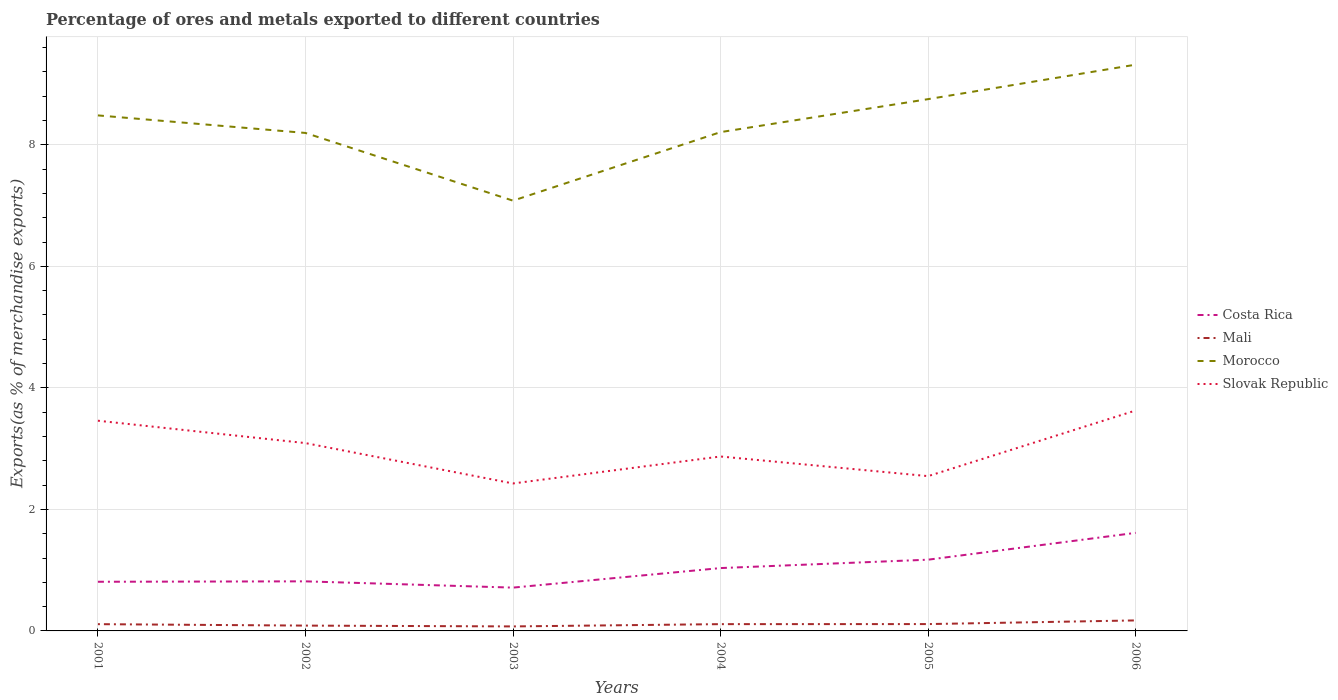Does the line corresponding to Mali intersect with the line corresponding to Slovak Republic?
Keep it short and to the point. No. Across all years, what is the maximum percentage of exports to different countries in Morocco?
Make the answer very short. 7.08. In which year was the percentage of exports to different countries in Costa Rica maximum?
Offer a terse response. 2003. What is the total percentage of exports to different countries in Costa Rica in the graph?
Ensure brevity in your answer.  0.1. What is the difference between the highest and the second highest percentage of exports to different countries in Morocco?
Give a very brief answer. 2.24. Is the percentage of exports to different countries in Morocco strictly greater than the percentage of exports to different countries in Mali over the years?
Offer a terse response. No. How many lines are there?
Provide a short and direct response. 4. How many years are there in the graph?
Your answer should be compact. 6. Are the values on the major ticks of Y-axis written in scientific E-notation?
Your answer should be compact. No. How are the legend labels stacked?
Make the answer very short. Vertical. What is the title of the graph?
Provide a succinct answer. Percentage of ores and metals exported to different countries. Does "Marshall Islands" appear as one of the legend labels in the graph?
Offer a terse response. No. What is the label or title of the X-axis?
Offer a terse response. Years. What is the label or title of the Y-axis?
Provide a succinct answer. Exports(as % of merchandise exports). What is the Exports(as % of merchandise exports) of Costa Rica in 2001?
Provide a short and direct response. 0.81. What is the Exports(as % of merchandise exports) of Mali in 2001?
Ensure brevity in your answer.  0.11. What is the Exports(as % of merchandise exports) in Morocco in 2001?
Offer a very short reply. 8.49. What is the Exports(as % of merchandise exports) of Slovak Republic in 2001?
Provide a succinct answer. 3.46. What is the Exports(as % of merchandise exports) of Costa Rica in 2002?
Your answer should be compact. 0.82. What is the Exports(as % of merchandise exports) in Mali in 2002?
Offer a very short reply. 0.09. What is the Exports(as % of merchandise exports) in Morocco in 2002?
Keep it short and to the point. 8.2. What is the Exports(as % of merchandise exports) in Slovak Republic in 2002?
Your response must be concise. 3.09. What is the Exports(as % of merchandise exports) of Costa Rica in 2003?
Ensure brevity in your answer.  0.71. What is the Exports(as % of merchandise exports) of Mali in 2003?
Ensure brevity in your answer.  0.07. What is the Exports(as % of merchandise exports) in Morocco in 2003?
Provide a short and direct response. 7.08. What is the Exports(as % of merchandise exports) of Slovak Republic in 2003?
Give a very brief answer. 2.43. What is the Exports(as % of merchandise exports) of Costa Rica in 2004?
Keep it short and to the point. 1.03. What is the Exports(as % of merchandise exports) of Mali in 2004?
Offer a very short reply. 0.11. What is the Exports(as % of merchandise exports) of Morocco in 2004?
Make the answer very short. 8.21. What is the Exports(as % of merchandise exports) of Slovak Republic in 2004?
Keep it short and to the point. 2.87. What is the Exports(as % of merchandise exports) in Costa Rica in 2005?
Ensure brevity in your answer.  1.17. What is the Exports(as % of merchandise exports) in Mali in 2005?
Your response must be concise. 0.11. What is the Exports(as % of merchandise exports) of Morocco in 2005?
Your response must be concise. 8.75. What is the Exports(as % of merchandise exports) in Slovak Republic in 2005?
Provide a short and direct response. 2.55. What is the Exports(as % of merchandise exports) in Costa Rica in 2006?
Your answer should be very brief. 1.61. What is the Exports(as % of merchandise exports) in Mali in 2006?
Provide a short and direct response. 0.17. What is the Exports(as % of merchandise exports) in Morocco in 2006?
Give a very brief answer. 9.32. What is the Exports(as % of merchandise exports) in Slovak Republic in 2006?
Offer a terse response. 3.63. Across all years, what is the maximum Exports(as % of merchandise exports) in Costa Rica?
Offer a very short reply. 1.61. Across all years, what is the maximum Exports(as % of merchandise exports) of Mali?
Your answer should be very brief. 0.17. Across all years, what is the maximum Exports(as % of merchandise exports) of Morocco?
Your answer should be very brief. 9.32. Across all years, what is the maximum Exports(as % of merchandise exports) in Slovak Republic?
Keep it short and to the point. 3.63. Across all years, what is the minimum Exports(as % of merchandise exports) of Costa Rica?
Offer a very short reply. 0.71. Across all years, what is the minimum Exports(as % of merchandise exports) of Mali?
Give a very brief answer. 0.07. Across all years, what is the minimum Exports(as % of merchandise exports) of Morocco?
Give a very brief answer. 7.08. Across all years, what is the minimum Exports(as % of merchandise exports) of Slovak Republic?
Offer a terse response. 2.43. What is the total Exports(as % of merchandise exports) of Costa Rica in the graph?
Offer a terse response. 6.16. What is the total Exports(as % of merchandise exports) in Mali in the graph?
Provide a succinct answer. 0.67. What is the total Exports(as % of merchandise exports) of Morocco in the graph?
Your answer should be very brief. 50.05. What is the total Exports(as % of merchandise exports) in Slovak Republic in the graph?
Make the answer very short. 18.03. What is the difference between the Exports(as % of merchandise exports) of Costa Rica in 2001 and that in 2002?
Make the answer very short. -0.01. What is the difference between the Exports(as % of merchandise exports) in Mali in 2001 and that in 2002?
Your answer should be very brief. 0.02. What is the difference between the Exports(as % of merchandise exports) in Morocco in 2001 and that in 2002?
Ensure brevity in your answer.  0.29. What is the difference between the Exports(as % of merchandise exports) in Slovak Republic in 2001 and that in 2002?
Provide a short and direct response. 0.37. What is the difference between the Exports(as % of merchandise exports) in Costa Rica in 2001 and that in 2003?
Provide a succinct answer. 0.1. What is the difference between the Exports(as % of merchandise exports) of Mali in 2001 and that in 2003?
Give a very brief answer. 0.04. What is the difference between the Exports(as % of merchandise exports) of Morocco in 2001 and that in 2003?
Offer a very short reply. 1.4. What is the difference between the Exports(as % of merchandise exports) in Slovak Republic in 2001 and that in 2003?
Offer a very short reply. 1.03. What is the difference between the Exports(as % of merchandise exports) in Costa Rica in 2001 and that in 2004?
Make the answer very short. -0.23. What is the difference between the Exports(as % of merchandise exports) of Mali in 2001 and that in 2004?
Keep it short and to the point. -0. What is the difference between the Exports(as % of merchandise exports) of Morocco in 2001 and that in 2004?
Your answer should be compact. 0.28. What is the difference between the Exports(as % of merchandise exports) in Slovak Republic in 2001 and that in 2004?
Offer a terse response. 0.59. What is the difference between the Exports(as % of merchandise exports) of Costa Rica in 2001 and that in 2005?
Offer a very short reply. -0.36. What is the difference between the Exports(as % of merchandise exports) in Mali in 2001 and that in 2005?
Offer a terse response. -0. What is the difference between the Exports(as % of merchandise exports) of Morocco in 2001 and that in 2005?
Provide a succinct answer. -0.27. What is the difference between the Exports(as % of merchandise exports) of Slovak Republic in 2001 and that in 2005?
Give a very brief answer. 0.91. What is the difference between the Exports(as % of merchandise exports) in Costa Rica in 2001 and that in 2006?
Ensure brevity in your answer.  -0.8. What is the difference between the Exports(as % of merchandise exports) in Mali in 2001 and that in 2006?
Keep it short and to the point. -0.06. What is the difference between the Exports(as % of merchandise exports) in Morocco in 2001 and that in 2006?
Offer a terse response. -0.84. What is the difference between the Exports(as % of merchandise exports) of Slovak Republic in 2001 and that in 2006?
Give a very brief answer. -0.17. What is the difference between the Exports(as % of merchandise exports) of Costa Rica in 2002 and that in 2003?
Make the answer very short. 0.1. What is the difference between the Exports(as % of merchandise exports) in Mali in 2002 and that in 2003?
Your answer should be compact. 0.01. What is the difference between the Exports(as % of merchandise exports) of Morocco in 2002 and that in 2003?
Give a very brief answer. 1.11. What is the difference between the Exports(as % of merchandise exports) in Slovak Republic in 2002 and that in 2003?
Offer a terse response. 0.66. What is the difference between the Exports(as % of merchandise exports) in Costa Rica in 2002 and that in 2004?
Your response must be concise. -0.22. What is the difference between the Exports(as % of merchandise exports) in Mali in 2002 and that in 2004?
Give a very brief answer. -0.02. What is the difference between the Exports(as % of merchandise exports) in Morocco in 2002 and that in 2004?
Keep it short and to the point. -0.01. What is the difference between the Exports(as % of merchandise exports) in Slovak Republic in 2002 and that in 2004?
Provide a short and direct response. 0.22. What is the difference between the Exports(as % of merchandise exports) in Costa Rica in 2002 and that in 2005?
Offer a terse response. -0.36. What is the difference between the Exports(as % of merchandise exports) of Mali in 2002 and that in 2005?
Make the answer very short. -0.03. What is the difference between the Exports(as % of merchandise exports) in Morocco in 2002 and that in 2005?
Offer a terse response. -0.56. What is the difference between the Exports(as % of merchandise exports) in Slovak Republic in 2002 and that in 2005?
Provide a short and direct response. 0.54. What is the difference between the Exports(as % of merchandise exports) in Costa Rica in 2002 and that in 2006?
Offer a very short reply. -0.8. What is the difference between the Exports(as % of merchandise exports) in Mali in 2002 and that in 2006?
Offer a very short reply. -0.09. What is the difference between the Exports(as % of merchandise exports) of Morocco in 2002 and that in 2006?
Give a very brief answer. -1.12. What is the difference between the Exports(as % of merchandise exports) of Slovak Republic in 2002 and that in 2006?
Ensure brevity in your answer.  -0.54. What is the difference between the Exports(as % of merchandise exports) of Costa Rica in 2003 and that in 2004?
Offer a terse response. -0.32. What is the difference between the Exports(as % of merchandise exports) of Mali in 2003 and that in 2004?
Ensure brevity in your answer.  -0.04. What is the difference between the Exports(as % of merchandise exports) in Morocco in 2003 and that in 2004?
Give a very brief answer. -1.13. What is the difference between the Exports(as % of merchandise exports) of Slovak Republic in 2003 and that in 2004?
Your answer should be compact. -0.44. What is the difference between the Exports(as % of merchandise exports) of Costa Rica in 2003 and that in 2005?
Offer a very short reply. -0.46. What is the difference between the Exports(as % of merchandise exports) of Mali in 2003 and that in 2005?
Provide a succinct answer. -0.04. What is the difference between the Exports(as % of merchandise exports) in Morocco in 2003 and that in 2005?
Offer a terse response. -1.67. What is the difference between the Exports(as % of merchandise exports) of Slovak Republic in 2003 and that in 2005?
Offer a very short reply. -0.12. What is the difference between the Exports(as % of merchandise exports) of Costa Rica in 2003 and that in 2006?
Keep it short and to the point. -0.9. What is the difference between the Exports(as % of merchandise exports) in Mali in 2003 and that in 2006?
Make the answer very short. -0.1. What is the difference between the Exports(as % of merchandise exports) in Morocco in 2003 and that in 2006?
Your answer should be compact. -2.24. What is the difference between the Exports(as % of merchandise exports) of Slovak Republic in 2003 and that in 2006?
Your response must be concise. -1.2. What is the difference between the Exports(as % of merchandise exports) of Costa Rica in 2004 and that in 2005?
Provide a short and direct response. -0.14. What is the difference between the Exports(as % of merchandise exports) of Mali in 2004 and that in 2005?
Offer a very short reply. -0. What is the difference between the Exports(as % of merchandise exports) of Morocco in 2004 and that in 2005?
Give a very brief answer. -0.54. What is the difference between the Exports(as % of merchandise exports) of Slovak Republic in 2004 and that in 2005?
Offer a very short reply. 0.32. What is the difference between the Exports(as % of merchandise exports) of Costa Rica in 2004 and that in 2006?
Keep it short and to the point. -0.58. What is the difference between the Exports(as % of merchandise exports) in Mali in 2004 and that in 2006?
Offer a terse response. -0.06. What is the difference between the Exports(as % of merchandise exports) in Morocco in 2004 and that in 2006?
Provide a short and direct response. -1.11. What is the difference between the Exports(as % of merchandise exports) in Slovak Republic in 2004 and that in 2006?
Offer a terse response. -0.76. What is the difference between the Exports(as % of merchandise exports) of Costa Rica in 2005 and that in 2006?
Offer a very short reply. -0.44. What is the difference between the Exports(as % of merchandise exports) of Mali in 2005 and that in 2006?
Your answer should be very brief. -0.06. What is the difference between the Exports(as % of merchandise exports) of Morocco in 2005 and that in 2006?
Make the answer very short. -0.57. What is the difference between the Exports(as % of merchandise exports) of Slovak Republic in 2005 and that in 2006?
Make the answer very short. -1.08. What is the difference between the Exports(as % of merchandise exports) of Costa Rica in 2001 and the Exports(as % of merchandise exports) of Mali in 2002?
Give a very brief answer. 0.72. What is the difference between the Exports(as % of merchandise exports) in Costa Rica in 2001 and the Exports(as % of merchandise exports) in Morocco in 2002?
Ensure brevity in your answer.  -7.39. What is the difference between the Exports(as % of merchandise exports) in Costa Rica in 2001 and the Exports(as % of merchandise exports) in Slovak Republic in 2002?
Your response must be concise. -2.28. What is the difference between the Exports(as % of merchandise exports) in Mali in 2001 and the Exports(as % of merchandise exports) in Morocco in 2002?
Ensure brevity in your answer.  -8.09. What is the difference between the Exports(as % of merchandise exports) of Mali in 2001 and the Exports(as % of merchandise exports) of Slovak Republic in 2002?
Make the answer very short. -2.98. What is the difference between the Exports(as % of merchandise exports) of Morocco in 2001 and the Exports(as % of merchandise exports) of Slovak Republic in 2002?
Offer a very short reply. 5.39. What is the difference between the Exports(as % of merchandise exports) of Costa Rica in 2001 and the Exports(as % of merchandise exports) of Mali in 2003?
Provide a succinct answer. 0.74. What is the difference between the Exports(as % of merchandise exports) of Costa Rica in 2001 and the Exports(as % of merchandise exports) of Morocco in 2003?
Keep it short and to the point. -6.27. What is the difference between the Exports(as % of merchandise exports) in Costa Rica in 2001 and the Exports(as % of merchandise exports) in Slovak Republic in 2003?
Provide a succinct answer. -1.62. What is the difference between the Exports(as % of merchandise exports) of Mali in 2001 and the Exports(as % of merchandise exports) of Morocco in 2003?
Your answer should be compact. -6.97. What is the difference between the Exports(as % of merchandise exports) in Mali in 2001 and the Exports(as % of merchandise exports) in Slovak Republic in 2003?
Offer a terse response. -2.32. What is the difference between the Exports(as % of merchandise exports) of Morocco in 2001 and the Exports(as % of merchandise exports) of Slovak Republic in 2003?
Your answer should be very brief. 6.06. What is the difference between the Exports(as % of merchandise exports) in Costa Rica in 2001 and the Exports(as % of merchandise exports) in Mali in 2004?
Ensure brevity in your answer.  0.7. What is the difference between the Exports(as % of merchandise exports) in Costa Rica in 2001 and the Exports(as % of merchandise exports) in Morocco in 2004?
Give a very brief answer. -7.4. What is the difference between the Exports(as % of merchandise exports) of Costa Rica in 2001 and the Exports(as % of merchandise exports) of Slovak Republic in 2004?
Ensure brevity in your answer.  -2.06. What is the difference between the Exports(as % of merchandise exports) in Mali in 2001 and the Exports(as % of merchandise exports) in Morocco in 2004?
Your answer should be compact. -8.1. What is the difference between the Exports(as % of merchandise exports) in Mali in 2001 and the Exports(as % of merchandise exports) in Slovak Republic in 2004?
Keep it short and to the point. -2.76. What is the difference between the Exports(as % of merchandise exports) of Morocco in 2001 and the Exports(as % of merchandise exports) of Slovak Republic in 2004?
Your answer should be compact. 5.61. What is the difference between the Exports(as % of merchandise exports) of Costa Rica in 2001 and the Exports(as % of merchandise exports) of Mali in 2005?
Provide a short and direct response. 0.7. What is the difference between the Exports(as % of merchandise exports) in Costa Rica in 2001 and the Exports(as % of merchandise exports) in Morocco in 2005?
Provide a succinct answer. -7.94. What is the difference between the Exports(as % of merchandise exports) in Costa Rica in 2001 and the Exports(as % of merchandise exports) in Slovak Republic in 2005?
Ensure brevity in your answer.  -1.74. What is the difference between the Exports(as % of merchandise exports) of Mali in 2001 and the Exports(as % of merchandise exports) of Morocco in 2005?
Provide a short and direct response. -8.64. What is the difference between the Exports(as % of merchandise exports) of Mali in 2001 and the Exports(as % of merchandise exports) of Slovak Republic in 2005?
Provide a short and direct response. -2.44. What is the difference between the Exports(as % of merchandise exports) in Morocco in 2001 and the Exports(as % of merchandise exports) in Slovak Republic in 2005?
Make the answer very short. 5.94. What is the difference between the Exports(as % of merchandise exports) in Costa Rica in 2001 and the Exports(as % of merchandise exports) in Mali in 2006?
Your answer should be compact. 0.64. What is the difference between the Exports(as % of merchandise exports) in Costa Rica in 2001 and the Exports(as % of merchandise exports) in Morocco in 2006?
Provide a short and direct response. -8.51. What is the difference between the Exports(as % of merchandise exports) in Costa Rica in 2001 and the Exports(as % of merchandise exports) in Slovak Republic in 2006?
Your answer should be very brief. -2.82. What is the difference between the Exports(as % of merchandise exports) of Mali in 2001 and the Exports(as % of merchandise exports) of Morocco in 2006?
Provide a short and direct response. -9.21. What is the difference between the Exports(as % of merchandise exports) in Mali in 2001 and the Exports(as % of merchandise exports) in Slovak Republic in 2006?
Your answer should be compact. -3.52. What is the difference between the Exports(as % of merchandise exports) in Morocco in 2001 and the Exports(as % of merchandise exports) in Slovak Republic in 2006?
Your response must be concise. 4.86. What is the difference between the Exports(as % of merchandise exports) in Costa Rica in 2002 and the Exports(as % of merchandise exports) in Mali in 2003?
Your response must be concise. 0.74. What is the difference between the Exports(as % of merchandise exports) of Costa Rica in 2002 and the Exports(as % of merchandise exports) of Morocco in 2003?
Ensure brevity in your answer.  -6.27. What is the difference between the Exports(as % of merchandise exports) of Costa Rica in 2002 and the Exports(as % of merchandise exports) of Slovak Republic in 2003?
Offer a very short reply. -1.61. What is the difference between the Exports(as % of merchandise exports) of Mali in 2002 and the Exports(as % of merchandise exports) of Morocco in 2003?
Ensure brevity in your answer.  -6.99. What is the difference between the Exports(as % of merchandise exports) of Mali in 2002 and the Exports(as % of merchandise exports) of Slovak Republic in 2003?
Provide a short and direct response. -2.34. What is the difference between the Exports(as % of merchandise exports) of Morocco in 2002 and the Exports(as % of merchandise exports) of Slovak Republic in 2003?
Give a very brief answer. 5.77. What is the difference between the Exports(as % of merchandise exports) in Costa Rica in 2002 and the Exports(as % of merchandise exports) in Mali in 2004?
Your answer should be compact. 0.7. What is the difference between the Exports(as % of merchandise exports) of Costa Rica in 2002 and the Exports(as % of merchandise exports) of Morocco in 2004?
Provide a short and direct response. -7.39. What is the difference between the Exports(as % of merchandise exports) in Costa Rica in 2002 and the Exports(as % of merchandise exports) in Slovak Republic in 2004?
Make the answer very short. -2.06. What is the difference between the Exports(as % of merchandise exports) in Mali in 2002 and the Exports(as % of merchandise exports) in Morocco in 2004?
Make the answer very short. -8.12. What is the difference between the Exports(as % of merchandise exports) in Mali in 2002 and the Exports(as % of merchandise exports) in Slovak Republic in 2004?
Make the answer very short. -2.78. What is the difference between the Exports(as % of merchandise exports) in Morocco in 2002 and the Exports(as % of merchandise exports) in Slovak Republic in 2004?
Your answer should be very brief. 5.33. What is the difference between the Exports(as % of merchandise exports) in Costa Rica in 2002 and the Exports(as % of merchandise exports) in Mali in 2005?
Keep it short and to the point. 0.7. What is the difference between the Exports(as % of merchandise exports) of Costa Rica in 2002 and the Exports(as % of merchandise exports) of Morocco in 2005?
Give a very brief answer. -7.94. What is the difference between the Exports(as % of merchandise exports) in Costa Rica in 2002 and the Exports(as % of merchandise exports) in Slovak Republic in 2005?
Provide a succinct answer. -1.73. What is the difference between the Exports(as % of merchandise exports) in Mali in 2002 and the Exports(as % of merchandise exports) in Morocco in 2005?
Provide a short and direct response. -8.67. What is the difference between the Exports(as % of merchandise exports) of Mali in 2002 and the Exports(as % of merchandise exports) of Slovak Republic in 2005?
Keep it short and to the point. -2.46. What is the difference between the Exports(as % of merchandise exports) in Morocco in 2002 and the Exports(as % of merchandise exports) in Slovak Republic in 2005?
Offer a terse response. 5.65. What is the difference between the Exports(as % of merchandise exports) of Costa Rica in 2002 and the Exports(as % of merchandise exports) of Mali in 2006?
Offer a very short reply. 0.64. What is the difference between the Exports(as % of merchandise exports) in Costa Rica in 2002 and the Exports(as % of merchandise exports) in Morocco in 2006?
Keep it short and to the point. -8.5. What is the difference between the Exports(as % of merchandise exports) of Costa Rica in 2002 and the Exports(as % of merchandise exports) of Slovak Republic in 2006?
Provide a short and direct response. -2.81. What is the difference between the Exports(as % of merchandise exports) in Mali in 2002 and the Exports(as % of merchandise exports) in Morocco in 2006?
Your response must be concise. -9.23. What is the difference between the Exports(as % of merchandise exports) of Mali in 2002 and the Exports(as % of merchandise exports) of Slovak Republic in 2006?
Give a very brief answer. -3.54. What is the difference between the Exports(as % of merchandise exports) of Morocco in 2002 and the Exports(as % of merchandise exports) of Slovak Republic in 2006?
Your answer should be compact. 4.57. What is the difference between the Exports(as % of merchandise exports) of Costa Rica in 2003 and the Exports(as % of merchandise exports) of Mali in 2004?
Give a very brief answer. 0.6. What is the difference between the Exports(as % of merchandise exports) of Costa Rica in 2003 and the Exports(as % of merchandise exports) of Morocco in 2004?
Keep it short and to the point. -7.5. What is the difference between the Exports(as % of merchandise exports) of Costa Rica in 2003 and the Exports(as % of merchandise exports) of Slovak Republic in 2004?
Provide a short and direct response. -2.16. What is the difference between the Exports(as % of merchandise exports) of Mali in 2003 and the Exports(as % of merchandise exports) of Morocco in 2004?
Provide a succinct answer. -8.14. What is the difference between the Exports(as % of merchandise exports) in Mali in 2003 and the Exports(as % of merchandise exports) in Slovak Republic in 2004?
Offer a very short reply. -2.8. What is the difference between the Exports(as % of merchandise exports) in Morocco in 2003 and the Exports(as % of merchandise exports) in Slovak Republic in 2004?
Your answer should be compact. 4.21. What is the difference between the Exports(as % of merchandise exports) of Costa Rica in 2003 and the Exports(as % of merchandise exports) of Mali in 2005?
Provide a succinct answer. 0.6. What is the difference between the Exports(as % of merchandise exports) in Costa Rica in 2003 and the Exports(as % of merchandise exports) in Morocco in 2005?
Give a very brief answer. -8.04. What is the difference between the Exports(as % of merchandise exports) in Costa Rica in 2003 and the Exports(as % of merchandise exports) in Slovak Republic in 2005?
Provide a succinct answer. -1.83. What is the difference between the Exports(as % of merchandise exports) of Mali in 2003 and the Exports(as % of merchandise exports) of Morocco in 2005?
Keep it short and to the point. -8.68. What is the difference between the Exports(as % of merchandise exports) of Mali in 2003 and the Exports(as % of merchandise exports) of Slovak Republic in 2005?
Your response must be concise. -2.47. What is the difference between the Exports(as % of merchandise exports) in Morocco in 2003 and the Exports(as % of merchandise exports) in Slovak Republic in 2005?
Your response must be concise. 4.53. What is the difference between the Exports(as % of merchandise exports) of Costa Rica in 2003 and the Exports(as % of merchandise exports) of Mali in 2006?
Your response must be concise. 0.54. What is the difference between the Exports(as % of merchandise exports) in Costa Rica in 2003 and the Exports(as % of merchandise exports) in Morocco in 2006?
Make the answer very short. -8.61. What is the difference between the Exports(as % of merchandise exports) of Costa Rica in 2003 and the Exports(as % of merchandise exports) of Slovak Republic in 2006?
Your answer should be very brief. -2.92. What is the difference between the Exports(as % of merchandise exports) in Mali in 2003 and the Exports(as % of merchandise exports) in Morocco in 2006?
Keep it short and to the point. -9.25. What is the difference between the Exports(as % of merchandise exports) in Mali in 2003 and the Exports(as % of merchandise exports) in Slovak Republic in 2006?
Offer a very short reply. -3.55. What is the difference between the Exports(as % of merchandise exports) of Morocco in 2003 and the Exports(as % of merchandise exports) of Slovak Republic in 2006?
Make the answer very short. 3.45. What is the difference between the Exports(as % of merchandise exports) of Costa Rica in 2004 and the Exports(as % of merchandise exports) of Mali in 2005?
Offer a very short reply. 0.92. What is the difference between the Exports(as % of merchandise exports) of Costa Rica in 2004 and the Exports(as % of merchandise exports) of Morocco in 2005?
Your answer should be compact. -7.72. What is the difference between the Exports(as % of merchandise exports) in Costa Rica in 2004 and the Exports(as % of merchandise exports) in Slovak Republic in 2005?
Your answer should be compact. -1.51. What is the difference between the Exports(as % of merchandise exports) in Mali in 2004 and the Exports(as % of merchandise exports) in Morocco in 2005?
Provide a succinct answer. -8.64. What is the difference between the Exports(as % of merchandise exports) of Mali in 2004 and the Exports(as % of merchandise exports) of Slovak Republic in 2005?
Offer a very short reply. -2.44. What is the difference between the Exports(as % of merchandise exports) in Morocco in 2004 and the Exports(as % of merchandise exports) in Slovak Republic in 2005?
Provide a succinct answer. 5.66. What is the difference between the Exports(as % of merchandise exports) in Costa Rica in 2004 and the Exports(as % of merchandise exports) in Mali in 2006?
Ensure brevity in your answer.  0.86. What is the difference between the Exports(as % of merchandise exports) in Costa Rica in 2004 and the Exports(as % of merchandise exports) in Morocco in 2006?
Give a very brief answer. -8.29. What is the difference between the Exports(as % of merchandise exports) of Costa Rica in 2004 and the Exports(as % of merchandise exports) of Slovak Republic in 2006?
Ensure brevity in your answer.  -2.59. What is the difference between the Exports(as % of merchandise exports) of Mali in 2004 and the Exports(as % of merchandise exports) of Morocco in 2006?
Make the answer very short. -9.21. What is the difference between the Exports(as % of merchandise exports) in Mali in 2004 and the Exports(as % of merchandise exports) in Slovak Republic in 2006?
Your answer should be compact. -3.52. What is the difference between the Exports(as % of merchandise exports) of Morocco in 2004 and the Exports(as % of merchandise exports) of Slovak Republic in 2006?
Keep it short and to the point. 4.58. What is the difference between the Exports(as % of merchandise exports) of Costa Rica in 2005 and the Exports(as % of merchandise exports) of Mali in 2006?
Make the answer very short. 1. What is the difference between the Exports(as % of merchandise exports) in Costa Rica in 2005 and the Exports(as % of merchandise exports) in Morocco in 2006?
Keep it short and to the point. -8.15. What is the difference between the Exports(as % of merchandise exports) in Costa Rica in 2005 and the Exports(as % of merchandise exports) in Slovak Republic in 2006?
Your response must be concise. -2.46. What is the difference between the Exports(as % of merchandise exports) of Mali in 2005 and the Exports(as % of merchandise exports) of Morocco in 2006?
Your answer should be compact. -9.21. What is the difference between the Exports(as % of merchandise exports) of Mali in 2005 and the Exports(as % of merchandise exports) of Slovak Republic in 2006?
Provide a short and direct response. -3.52. What is the difference between the Exports(as % of merchandise exports) of Morocco in 2005 and the Exports(as % of merchandise exports) of Slovak Republic in 2006?
Offer a terse response. 5.12. What is the average Exports(as % of merchandise exports) of Costa Rica per year?
Offer a terse response. 1.03. What is the average Exports(as % of merchandise exports) in Mali per year?
Provide a short and direct response. 0.11. What is the average Exports(as % of merchandise exports) of Morocco per year?
Provide a short and direct response. 8.34. What is the average Exports(as % of merchandise exports) of Slovak Republic per year?
Offer a terse response. 3. In the year 2001, what is the difference between the Exports(as % of merchandise exports) in Costa Rica and Exports(as % of merchandise exports) in Mali?
Give a very brief answer. 0.7. In the year 2001, what is the difference between the Exports(as % of merchandise exports) of Costa Rica and Exports(as % of merchandise exports) of Morocco?
Provide a short and direct response. -7.68. In the year 2001, what is the difference between the Exports(as % of merchandise exports) of Costa Rica and Exports(as % of merchandise exports) of Slovak Republic?
Provide a succinct answer. -2.65. In the year 2001, what is the difference between the Exports(as % of merchandise exports) of Mali and Exports(as % of merchandise exports) of Morocco?
Keep it short and to the point. -8.37. In the year 2001, what is the difference between the Exports(as % of merchandise exports) of Mali and Exports(as % of merchandise exports) of Slovak Republic?
Offer a very short reply. -3.35. In the year 2001, what is the difference between the Exports(as % of merchandise exports) in Morocco and Exports(as % of merchandise exports) in Slovak Republic?
Keep it short and to the point. 5.03. In the year 2002, what is the difference between the Exports(as % of merchandise exports) of Costa Rica and Exports(as % of merchandise exports) of Mali?
Give a very brief answer. 0.73. In the year 2002, what is the difference between the Exports(as % of merchandise exports) in Costa Rica and Exports(as % of merchandise exports) in Morocco?
Provide a succinct answer. -7.38. In the year 2002, what is the difference between the Exports(as % of merchandise exports) of Costa Rica and Exports(as % of merchandise exports) of Slovak Republic?
Offer a very short reply. -2.28. In the year 2002, what is the difference between the Exports(as % of merchandise exports) in Mali and Exports(as % of merchandise exports) in Morocco?
Ensure brevity in your answer.  -8.11. In the year 2002, what is the difference between the Exports(as % of merchandise exports) in Mali and Exports(as % of merchandise exports) in Slovak Republic?
Keep it short and to the point. -3. In the year 2002, what is the difference between the Exports(as % of merchandise exports) in Morocco and Exports(as % of merchandise exports) in Slovak Republic?
Your response must be concise. 5.1. In the year 2003, what is the difference between the Exports(as % of merchandise exports) of Costa Rica and Exports(as % of merchandise exports) of Mali?
Give a very brief answer. 0.64. In the year 2003, what is the difference between the Exports(as % of merchandise exports) of Costa Rica and Exports(as % of merchandise exports) of Morocco?
Offer a very short reply. -6.37. In the year 2003, what is the difference between the Exports(as % of merchandise exports) in Costa Rica and Exports(as % of merchandise exports) in Slovak Republic?
Offer a terse response. -1.71. In the year 2003, what is the difference between the Exports(as % of merchandise exports) of Mali and Exports(as % of merchandise exports) of Morocco?
Your response must be concise. -7.01. In the year 2003, what is the difference between the Exports(as % of merchandise exports) of Mali and Exports(as % of merchandise exports) of Slovak Republic?
Keep it short and to the point. -2.35. In the year 2003, what is the difference between the Exports(as % of merchandise exports) in Morocco and Exports(as % of merchandise exports) in Slovak Republic?
Your response must be concise. 4.65. In the year 2004, what is the difference between the Exports(as % of merchandise exports) in Costa Rica and Exports(as % of merchandise exports) in Mali?
Your answer should be very brief. 0.92. In the year 2004, what is the difference between the Exports(as % of merchandise exports) in Costa Rica and Exports(as % of merchandise exports) in Morocco?
Your answer should be very brief. -7.18. In the year 2004, what is the difference between the Exports(as % of merchandise exports) of Costa Rica and Exports(as % of merchandise exports) of Slovak Republic?
Your response must be concise. -1.84. In the year 2004, what is the difference between the Exports(as % of merchandise exports) in Mali and Exports(as % of merchandise exports) in Morocco?
Make the answer very short. -8.1. In the year 2004, what is the difference between the Exports(as % of merchandise exports) of Mali and Exports(as % of merchandise exports) of Slovak Republic?
Make the answer very short. -2.76. In the year 2004, what is the difference between the Exports(as % of merchandise exports) of Morocco and Exports(as % of merchandise exports) of Slovak Republic?
Your answer should be very brief. 5.34. In the year 2005, what is the difference between the Exports(as % of merchandise exports) of Costa Rica and Exports(as % of merchandise exports) of Mali?
Offer a terse response. 1.06. In the year 2005, what is the difference between the Exports(as % of merchandise exports) in Costa Rica and Exports(as % of merchandise exports) in Morocco?
Provide a succinct answer. -7.58. In the year 2005, what is the difference between the Exports(as % of merchandise exports) in Costa Rica and Exports(as % of merchandise exports) in Slovak Republic?
Keep it short and to the point. -1.38. In the year 2005, what is the difference between the Exports(as % of merchandise exports) in Mali and Exports(as % of merchandise exports) in Morocco?
Your response must be concise. -8.64. In the year 2005, what is the difference between the Exports(as % of merchandise exports) in Mali and Exports(as % of merchandise exports) in Slovak Republic?
Make the answer very short. -2.44. In the year 2005, what is the difference between the Exports(as % of merchandise exports) in Morocco and Exports(as % of merchandise exports) in Slovak Republic?
Keep it short and to the point. 6.21. In the year 2006, what is the difference between the Exports(as % of merchandise exports) in Costa Rica and Exports(as % of merchandise exports) in Mali?
Provide a succinct answer. 1.44. In the year 2006, what is the difference between the Exports(as % of merchandise exports) in Costa Rica and Exports(as % of merchandise exports) in Morocco?
Keep it short and to the point. -7.71. In the year 2006, what is the difference between the Exports(as % of merchandise exports) of Costa Rica and Exports(as % of merchandise exports) of Slovak Republic?
Ensure brevity in your answer.  -2.01. In the year 2006, what is the difference between the Exports(as % of merchandise exports) of Mali and Exports(as % of merchandise exports) of Morocco?
Your response must be concise. -9.15. In the year 2006, what is the difference between the Exports(as % of merchandise exports) of Mali and Exports(as % of merchandise exports) of Slovak Republic?
Make the answer very short. -3.46. In the year 2006, what is the difference between the Exports(as % of merchandise exports) in Morocco and Exports(as % of merchandise exports) in Slovak Republic?
Provide a succinct answer. 5.69. What is the ratio of the Exports(as % of merchandise exports) in Costa Rica in 2001 to that in 2002?
Your answer should be very brief. 0.99. What is the ratio of the Exports(as % of merchandise exports) in Mali in 2001 to that in 2002?
Offer a terse response. 1.27. What is the ratio of the Exports(as % of merchandise exports) of Morocco in 2001 to that in 2002?
Provide a short and direct response. 1.04. What is the ratio of the Exports(as % of merchandise exports) in Slovak Republic in 2001 to that in 2002?
Ensure brevity in your answer.  1.12. What is the ratio of the Exports(as % of merchandise exports) in Costa Rica in 2001 to that in 2003?
Ensure brevity in your answer.  1.14. What is the ratio of the Exports(as % of merchandise exports) in Mali in 2001 to that in 2003?
Give a very brief answer. 1.5. What is the ratio of the Exports(as % of merchandise exports) of Morocco in 2001 to that in 2003?
Offer a very short reply. 1.2. What is the ratio of the Exports(as % of merchandise exports) in Slovak Republic in 2001 to that in 2003?
Your response must be concise. 1.43. What is the ratio of the Exports(as % of merchandise exports) in Costa Rica in 2001 to that in 2004?
Your answer should be very brief. 0.78. What is the ratio of the Exports(as % of merchandise exports) in Morocco in 2001 to that in 2004?
Provide a short and direct response. 1.03. What is the ratio of the Exports(as % of merchandise exports) of Slovak Republic in 2001 to that in 2004?
Give a very brief answer. 1.21. What is the ratio of the Exports(as % of merchandise exports) of Costa Rica in 2001 to that in 2005?
Provide a succinct answer. 0.69. What is the ratio of the Exports(as % of merchandise exports) of Mali in 2001 to that in 2005?
Give a very brief answer. 0.99. What is the ratio of the Exports(as % of merchandise exports) of Morocco in 2001 to that in 2005?
Provide a succinct answer. 0.97. What is the ratio of the Exports(as % of merchandise exports) of Slovak Republic in 2001 to that in 2005?
Provide a succinct answer. 1.36. What is the ratio of the Exports(as % of merchandise exports) in Costa Rica in 2001 to that in 2006?
Your answer should be compact. 0.5. What is the ratio of the Exports(as % of merchandise exports) in Mali in 2001 to that in 2006?
Offer a terse response. 0.64. What is the ratio of the Exports(as % of merchandise exports) in Morocco in 2001 to that in 2006?
Ensure brevity in your answer.  0.91. What is the ratio of the Exports(as % of merchandise exports) in Slovak Republic in 2001 to that in 2006?
Make the answer very short. 0.95. What is the ratio of the Exports(as % of merchandise exports) in Costa Rica in 2002 to that in 2003?
Your answer should be very brief. 1.14. What is the ratio of the Exports(as % of merchandise exports) of Mali in 2002 to that in 2003?
Provide a succinct answer. 1.18. What is the ratio of the Exports(as % of merchandise exports) of Morocco in 2002 to that in 2003?
Keep it short and to the point. 1.16. What is the ratio of the Exports(as % of merchandise exports) of Slovak Republic in 2002 to that in 2003?
Your answer should be very brief. 1.27. What is the ratio of the Exports(as % of merchandise exports) in Costa Rica in 2002 to that in 2004?
Your answer should be compact. 0.79. What is the ratio of the Exports(as % of merchandise exports) in Mali in 2002 to that in 2004?
Ensure brevity in your answer.  0.78. What is the ratio of the Exports(as % of merchandise exports) in Slovak Republic in 2002 to that in 2004?
Give a very brief answer. 1.08. What is the ratio of the Exports(as % of merchandise exports) in Costa Rica in 2002 to that in 2005?
Provide a succinct answer. 0.7. What is the ratio of the Exports(as % of merchandise exports) in Mali in 2002 to that in 2005?
Keep it short and to the point. 0.78. What is the ratio of the Exports(as % of merchandise exports) of Morocco in 2002 to that in 2005?
Keep it short and to the point. 0.94. What is the ratio of the Exports(as % of merchandise exports) of Slovak Republic in 2002 to that in 2005?
Provide a short and direct response. 1.21. What is the ratio of the Exports(as % of merchandise exports) in Costa Rica in 2002 to that in 2006?
Your answer should be compact. 0.51. What is the ratio of the Exports(as % of merchandise exports) of Mali in 2002 to that in 2006?
Provide a short and direct response. 0.51. What is the ratio of the Exports(as % of merchandise exports) in Morocco in 2002 to that in 2006?
Offer a very short reply. 0.88. What is the ratio of the Exports(as % of merchandise exports) of Slovak Republic in 2002 to that in 2006?
Give a very brief answer. 0.85. What is the ratio of the Exports(as % of merchandise exports) of Costa Rica in 2003 to that in 2004?
Keep it short and to the point. 0.69. What is the ratio of the Exports(as % of merchandise exports) of Mali in 2003 to that in 2004?
Offer a terse response. 0.66. What is the ratio of the Exports(as % of merchandise exports) of Morocco in 2003 to that in 2004?
Your response must be concise. 0.86. What is the ratio of the Exports(as % of merchandise exports) in Slovak Republic in 2003 to that in 2004?
Provide a short and direct response. 0.85. What is the ratio of the Exports(as % of merchandise exports) in Costa Rica in 2003 to that in 2005?
Your answer should be compact. 0.61. What is the ratio of the Exports(as % of merchandise exports) in Mali in 2003 to that in 2005?
Provide a succinct answer. 0.66. What is the ratio of the Exports(as % of merchandise exports) of Morocco in 2003 to that in 2005?
Provide a short and direct response. 0.81. What is the ratio of the Exports(as % of merchandise exports) in Slovak Republic in 2003 to that in 2005?
Offer a very short reply. 0.95. What is the ratio of the Exports(as % of merchandise exports) in Costa Rica in 2003 to that in 2006?
Offer a terse response. 0.44. What is the ratio of the Exports(as % of merchandise exports) in Mali in 2003 to that in 2006?
Make the answer very short. 0.43. What is the ratio of the Exports(as % of merchandise exports) in Morocco in 2003 to that in 2006?
Keep it short and to the point. 0.76. What is the ratio of the Exports(as % of merchandise exports) in Slovak Republic in 2003 to that in 2006?
Your response must be concise. 0.67. What is the ratio of the Exports(as % of merchandise exports) in Costa Rica in 2004 to that in 2005?
Ensure brevity in your answer.  0.88. What is the ratio of the Exports(as % of merchandise exports) in Mali in 2004 to that in 2005?
Give a very brief answer. 0.99. What is the ratio of the Exports(as % of merchandise exports) in Morocco in 2004 to that in 2005?
Keep it short and to the point. 0.94. What is the ratio of the Exports(as % of merchandise exports) of Slovak Republic in 2004 to that in 2005?
Offer a very short reply. 1.13. What is the ratio of the Exports(as % of merchandise exports) of Costa Rica in 2004 to that in 2006?
Provide a short and direct response. 0.64. What is the ratio of the Exports(as % of merchandise exports) of Mali in 2004 to that in 2006?
Provide a succinct answer. 0.65. What is the ratio of the Exports(as % of merchandise exports) in Morocco in 2004 to that in 2006?
Ensure brevity in your answer.  0.88. What is the ratio of the Exports(as % of merchandise exports) of Slovak Republic in 2004 to that in 2006?
Give a very brief answer. 0.79. What is the ratio of the Exports(as % of merchandise exports) in Costa Rica in 2005 to that in 2006?
Provide a succinct answer. 0.73. What is the ratio of the Exports(as % of merchandise exports) of Mali in 2005 to that in 2006?
Provide a short and direct response. 0.65. What is the ratio of the Exports(as % of merchandise exports) in Morocco in 2005 to that in 2006?
Your response must be concise. 0.94. What is the ratio of the Exports(as % of merchandise exports) of Slovak Republic in 2005 to that in 2006?
Your answer should be compact. 0.7. What is the difference between the highest and the second highest Exports(as % of merchandise exports) in Costa Rica?
Your answer should be very brief. 0.44. What is the difference between the highest and the second highest Exports(as % of merchandise exports) in Mali?
Make the answer very short. 0.06. What is the difference between the highest and the second highest Exports(as % of merchandise exports) in Morocco?
Your answer should be very brief. 0.57. What is the difference between the highest and the second highest Exports(as % of merchandise exports) of Slovak Republic?
Offer a very short reply. 0.17. What is the difference between the highest and the lowest Exports(as % of merchandise exports) of Costa Rica?
Make the answer very short. 0.9. What is the difference between the highest and the lowest Exports(as % of merchandise exports) of Mali?
Provide a short and direct response. 0.1. What is the difference between the highest and the lowest Exports(as % of merchandise exports) of Morocco?
Offer a very short reply. 2.24. What is the difference between the highest and the lowest Exports(as % of merchandise exports) of Slovak Republic?
Your answer should be very brief. 1.2. 